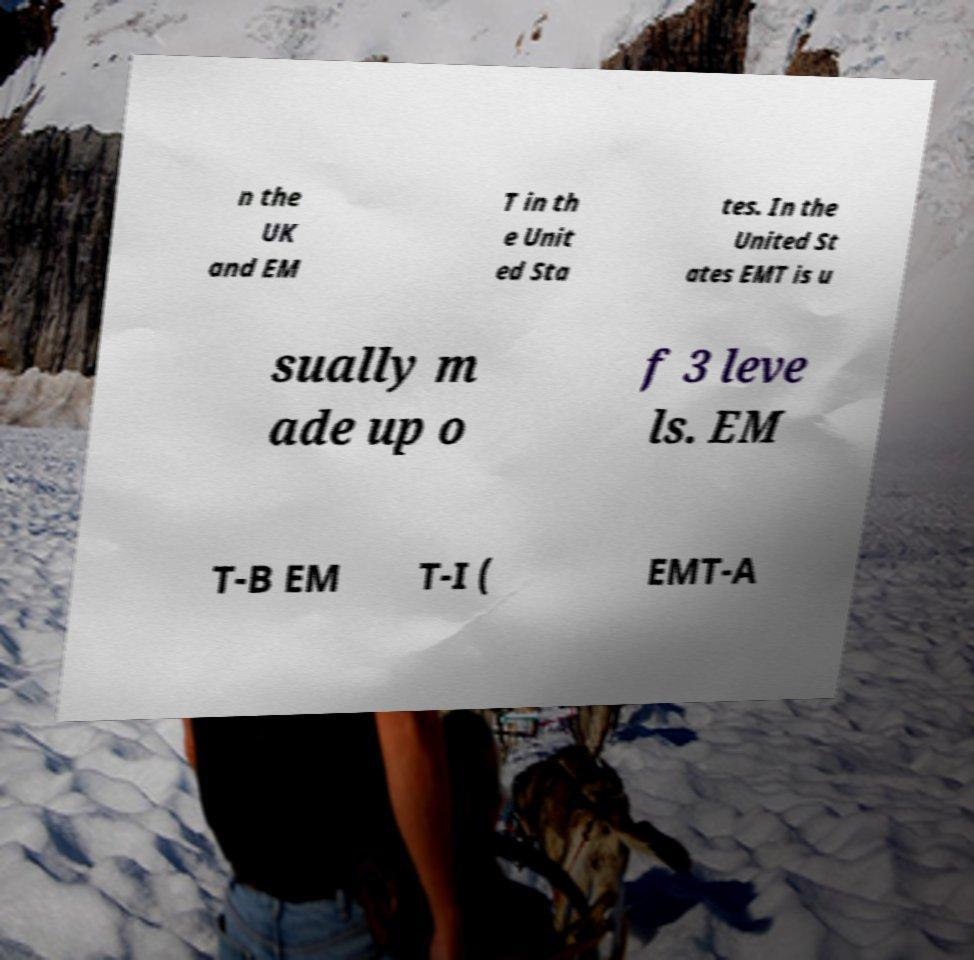For documentation purposes, I need the text within this image transcribed. Could you provide that? n the UK and EM T in th e Unit ed Sta tes. In the United St ates EMT is u sually m ade up o f 3 leve ls. EM T-B EM T-I ( EMT-A 